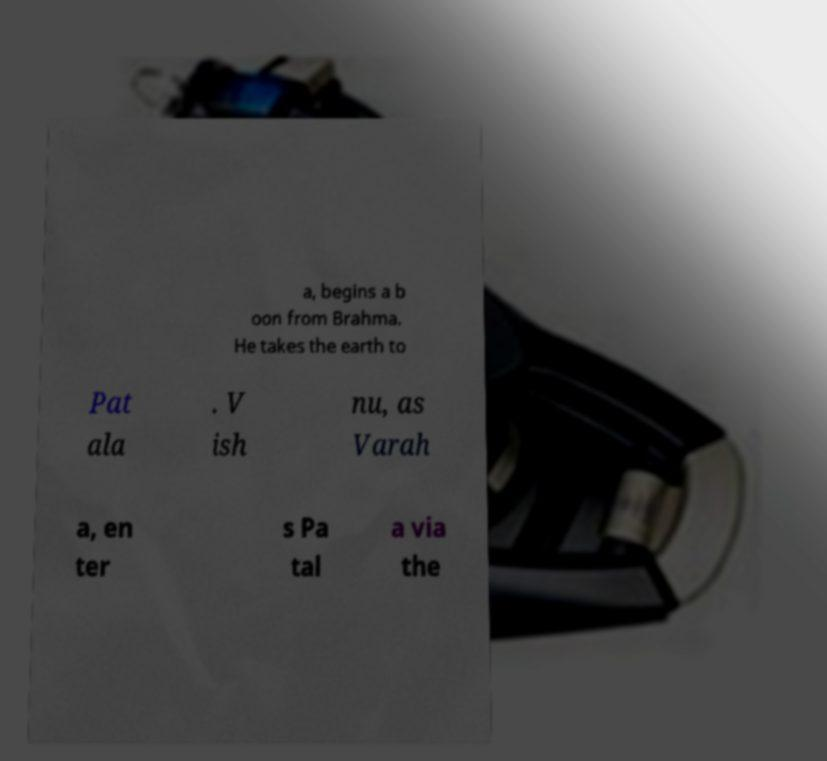Please read and relay the text visible in this image. What does it say? a, begins a b oon from Brahma. He takes the earth to Pat ala . V ish nu, as Varah a, en ter s Pa tal a via the 